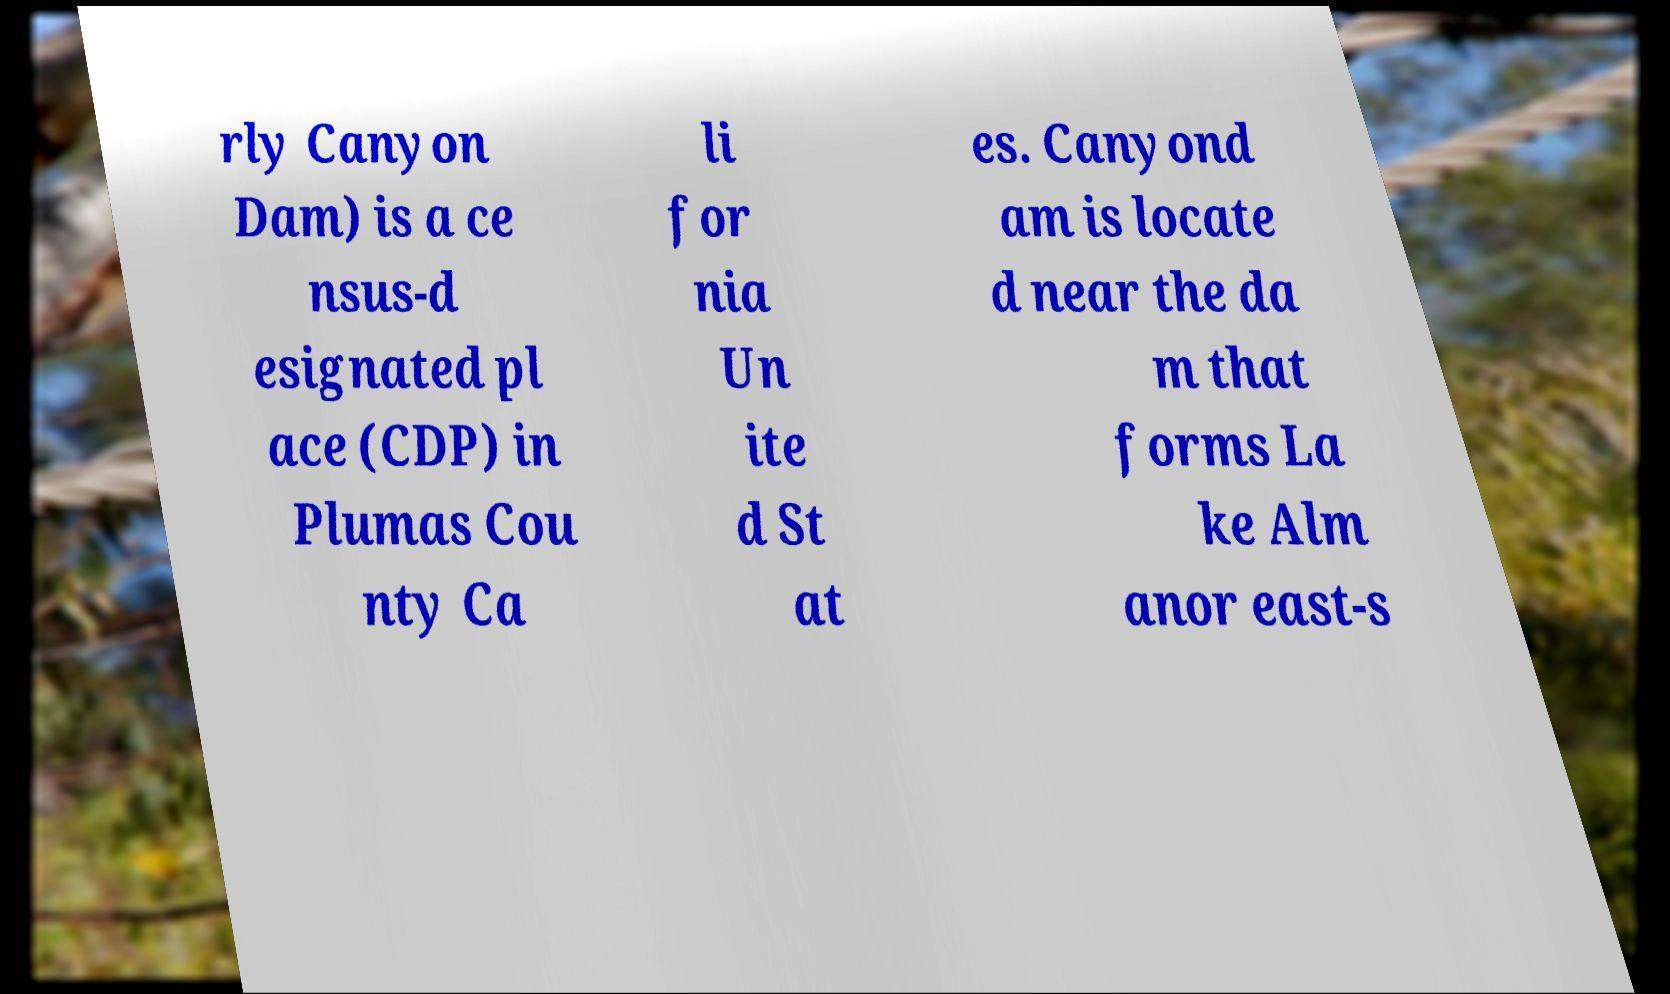Could you extract and type out the text from this image? rly Canyon Dam) is a ce nsus-d esignated pl ace (CDP) in Plumas Cou nty Ca li for nia Un ite d St at es. Canyond am is locate d near the da m that forms La ke Alm anor east-s 